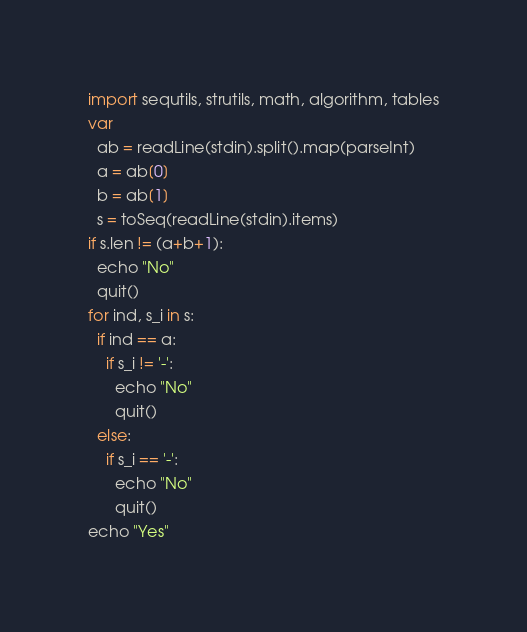Convert code to text. <code><loc_0><loc_0><loc_500><loc_500><_Nim_>import sequtils, strutils, math, algorithm, tables
var
  ab = readLine(stdin).split().map(parseInt)
  a = ab[0]
  b = ab[1]
  s = toSeq(readLine(stdin).items)
if s.len != (a+b+1):
  echo "No"
  quit()
for ind, s_i in s:
  if ind == a:
    if s_i != '-':
      echo "No"
      quit()
  else:
    if s_i == '-':
      echo "No"
      quit()
echo "Yes"</code> 